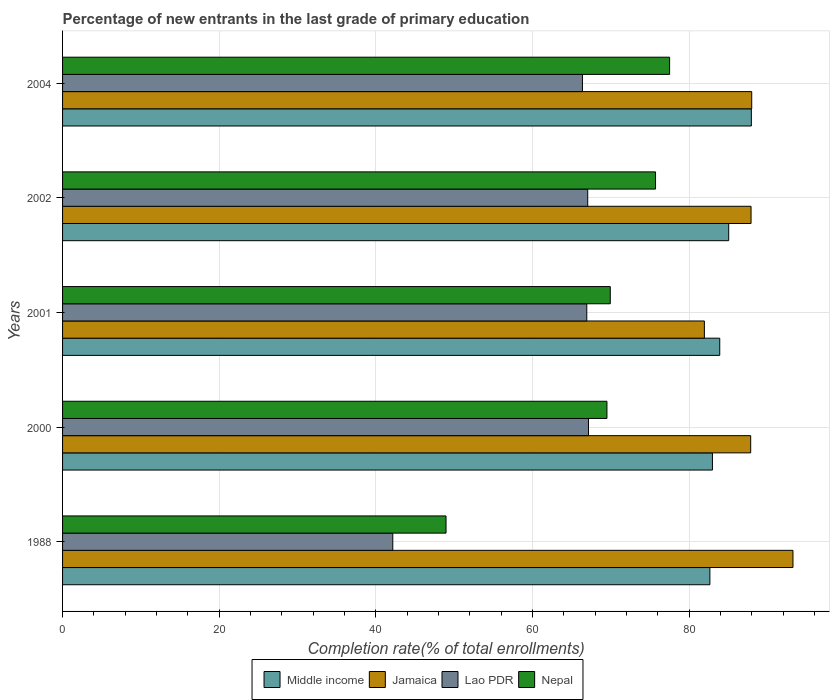How many groups of bars are there?
Provide a short and direct response. 5. How many bars are there on the 3rd tick from the top?
Your answer should be very brief. 4. How many bars are there on the 4th tick from the bottom?
Your answer should be very brief. 4. What is the percentage of new entrants in Jamaica in 2001?
Keep it short and to the point. 81.95. Across all years, what is the maximum percentage of new entrants in Jamaica?
Ensure brevity in your answer.  93.26. Across all years, what is the minimum percentage of new entrants in Nepal?
Your answer should be compact. 48.96. In which year was the percentage of new entrants in Lao PDR minimum?
Give a very brief answer. 1988. What is the total percentage of new entrants in Middle income in the graph?
Ensure brevity in your answer.  422.53. What is the difference between the percentage of new entrants in Middle income in 2000 and that in 2001?
Give a very brief answer. -0.93. What is the difference between the percentage of new entrants in Middle income in 2004 and the percentage of new entrants in Lao PDR in 2002?
Keep it short and to the point. 20.89. What is the average percentage of new entrants in Lao PDR per year?
Make the answer very short. 61.93. In the year 1988, what is the difference between the percentage of new entrants in Lao PDR and percentage of new entrants in Nepal?
Your answer should be very brief. -6.8. In how many years, is the percentage of new entrants in Jamaica greater than 24 %?
Your answer should be very brief. 5. What is the ratio of the percentage of new entrants in Nepal in 1988 to that in 2004?
Keep it short and to the point. 0.63. Is the percentage of new entrants in Middle income in 1988 less than that in 2004?
Your answer should be compact. Yes. What is the difference between the highest and the second highest percentage of new entrants in Nepal?
Your answer should be compact. 1.8. What is the difference between the highest and the lowest percentage of new entrants in Middle income?
Make the answer very short. 5.29. In how many years, is the percentage of new entrants in Nepal greater than the average percentage of new entrants in Nepal taken over all years?
Keep it short and to the point. 4. Is the sum of the percentage of new entrants in Middle income in 2000 and 2004 greater than the maximum percentage of new entrants in Nepal across all years?
Ensure brevity in your answer.  Yes. Is it the case that in every year, the sum of the percentage of new entrants in Jamaica and percentage of new entrants in Lao PDR is greater than the sum of percentage of new entrants in Nepal and percentage of new entrants in Middle income?
Provide a short and direct response. No. What does the 1st bar from the top in 2001 represents?
Ensure brevity in your answer.  Nepal. What does the 1st bar from the bottom in 2001 represents?
Offer a very short reply. Middle income. Is it the case that in every year, the sum of the percentage of new entrants in Jamaica and percentage of new entrants in Lao PDR is greater than the percentage of new entrants in Middle income?
Offer a very short reply. Yes. How many years are there in the graph?
Give a very brief answer. 5. What is the difference between two consecutive major ticks on the X-axis?
Ensure brevity in your answer.  20. Are the values on the major ticks of X-axis written in scientific E-notation?
Keep it short and to the point. No. Where does the legend appear in the graph?
Your response must be concise. Bottom center. How are the legend labels stacked?
Your answer should be compact. Horizontal. What is the title of the graph?
Your answer should be very brief. Percentage of new entrants in the last grade of primary education. Does "Gabon" appear as one of the legend labels in the graph?
Your answer should be compact. No. What is the label or title of the X-axis?
Provide a succinct answer. Completion rate(% of total enrollments). What is the Completion rate(% of total enrollments) in Middle income in 1988?
Ensure brevity in your answer.  82.65. What is the Completion rate(% of total enrollments) of Jamaica in 1988?
Ensure brevity in your answer.  93.26. What is the Completion rate(% of total enrollments) of Lao PDR in 1988?
Give a very brief answer. 42.16. What is the Completion rate(% of total enrollments) in Nepal in 1988?
Ensure brevity in your answer.  48.96. What is the Completion rate(% of total enrollments) in Middle income in 2000?
Your answer should be very brief. 82.97. What is the Completion rate(% of total enrollments) of Jamaica in 2000?
Make the answer very short. 87.86. What is the Completion rate(% of total enrollments) of Lao PDR in 2000?
Your answer should be compact. 67.15. What is the Completion rate(% of total enrollments) in Nepal in 2000?
Offer a very short reply. 69.51. What is the Completion rate(% of total enrollments) of Middle income in 2001?
Offer a terse response. 83.91. What is the Completion rate(% of total enrollments) in Jamaica in 2001?
Give a very brief answer. 81.95. What is the Completion rate(% of total enrollments) in Lao PDR in 2001?
Keep it short and to the point. 66.93. What is the Completion rate(% of total enrollments) of Nepal in 2001?
Offer a very short reply. 69.93. What is the Completion rate(% of total enrollments) of Middle income in 2002?
Your response must be concise. 85.05. What is the Completion rate(% of total enrollments) in Jamaica in 2002?
Your answer should be compact. 87.91. What is the Completion rate(% of total enrollments) of Lao PDR in 2002?
Offer a terse response. 67.05. What is the Completion rate(% of total enrollments) of Nepal in 2002?
Give a very brief answer. 75.71. What is the Completion rate(% of total enrollments) of Middle income in 2004?
Your answer should be compact. 87.94. What is the Completion rate(% of total enrollments) in Jamaica in 2004?
Ensure brevity in your answer.  87.99. What is the Completion rate(% of total enrollments) of Lao PDR in 2004?
Ensure brevity in your answer.  66.38. What is the Completion rate(% of total enrollments) of Nepal in 2004?
Offer a very short reply. 77.51. Across all years, what is the maximum Completion rate(% of total enrollments) in Middle income?
Provide a short and direct response. 87.94. Across all years, what is the maximum Completion rate(% of total enrollments) in Jamaica?
Your answer should be very brief. 93.26. Across all years, what is the maximum Completion rate(% of total enrollments) in Lao PDR?
Offer a very short reply. 67.15. Across all years, what is the maximum Completion rate(% of total enrollments) of Nepal?
Offer a very short reply. 77.51. Across all years, what is the minimum Completion rate(% of total enrollments) in Middle income?
Your answer should be very brief. 82.65. Across all years, what is the minimum Completion rate(% of total enrollments) in Jamaica?
Provide a short and direct response. 81.95. Across all years, what is the minimum Completion rate(% of total enrollments) in Lao PDR?
Your answer should be very brief. 42.16. Across all years, what is the minimum Completion rate(% of total enrollments) in Nepal?
Offer a very short reply. 48.96. What is the total Completion rate(% of total enrollments) of Middle income in the graph?
Provide a succinct answer. 422.53. What is the total Completion rate(% of total enrollments) of Jamaica in the graph?
Ensure brevity in your answer.  438.96. What is the total Completion rate(% of total enrollments) in Lao PDR in the graph?
Your answer should be compact. 309.67. What is the total Completion rate(% of total enrollments) of Nepal in the graph?
Your answer should be compact. 341.61. What is the difference between the Completion rate(% of total enrollments) in Middle income in 1988 and that in 2000?
Ensure brevity in your answer.  -0.33. What is the difference between the Completion rate(% of total enrollments) in Jamaica in 1988 and that in 2000?
Your answer should be very brief. 5.4. What is the difference between the Completion rate(% of total enrollments) in Lao PDR in 1988 and that in 2000?
Offer a terse response. -24.99. What is the difference between the Completion rate(% of total enrollments) in Nepal in 1988 and that in 2000?
Provide a succinct answer. -20.55. What is the difference between the Completion rate(% of total enrollments) of Middle income in 1988 and that in 2001?
Ensure brevity in your answer.  -1.26. What is the difference between the Completion rate(% of total enrollments) in Jamaica in 1988 and that in 2001?
Offer a terse response. 11.31. What is the difference between the Completion rate(% of total enrollments) in Lao PDR in 1988 and that in 2001?
Ensure brevity in your answer.  -24.77. What is the difference between the Completion rate(% of total enrollments) of Nepal in 1988 and that in 2001?
Ensure brevity in your answer.  -20.97. What is the difference between the Completion rate(% of total enrollments) of Middle income in 1988 and that in 2002?
Provide a short and direct response. -2.4. What is the difference between the Completion rate(% of total enrollments) in Jamaica in 1988 and that in 2002?
Ensure brevity in your answer.  5.35. What is the difference between the Completion rate(% of total enrollments) of Lao PDR in 1988 and that in 2002?
Give a very brief answer. -24.89. What is the difference between the Completion rate(% of total enrollments) in Nepal in 1988 and that in 2002?
Provide a short and direct response. -26.75. What is the difference between the Completion rate(% of total enrollments) in Middle income in 1988 and that in 2004?
Offer a terse response. -5.29. What is the difference between the Completion rate(% of total enrollments) of Jamaica in 1988 and that in 2004?
Offer a terse response. 5.27. What is the difference between the Completion rate(% of total enrollments) in Lao PDR in 1988 and that in 2004?
Keep it short and to the point. -24.22. What is the difference between the Completion rate(% of total enrollments) in Nepal in 1988 and that in 2004?
Your answer should be very brief. -28.55. What is the difference between the Completion rate(% of total enrollments) of Middle income in 2000 and that in 2001?
Ensure brevity in your answer.  -0.93. What is the difference between the Completion rate(% of total enrollments) of Jamaica in 2000 and that in 2001?
Your response must be concise. 5.91. What is the difference between the Completion rate(% of total enrollments) of Lao PDR in 2000 and that in 2001?
Give a very brief answer. 0.22. What is the difference between the Completion rate(% of total enrollments) in Nepal in 2000 and that in 2001?
Give a very brief answer. -0.43. What is the difference between the Completion rate(% of total enrollments) of Middle income in 2000 and that in 2002?
Give a very brief answer. -2.08. What is the difference between the Completion rate(% of total enrollments) in Jamaica in 2000 and that in 2002?
Provide a succinct answer. -0.05. What is the difference between the Completion rate(% of total enrollments) of Lao PDR in 2000 and that in 2002?
Provide a short and direct response. 0.1. What is the difference between the Completion rate(% of total enrollments) in Nepal in 2000 and that in 2002?
Keep it short and to the point. -6.2. What is the difference between the Completion rate(% of total enrollments) in Middle income in 2000 and that in 2004?
Ensure brevity in your answer.  -4.97. What is the difference between the Completion rate(% of total enrollments) of Jamaica in 2000 and that in 2004?
Your response must be concise. -0.13. What is the difference between the Completion rate(% of total enrollments) of Lao PDR in 2000 and that in 2004?
Keep it short and to the point. 0.77. What is the difference between the Completion rate(% of total enrollments) of Nepal in 2000 and that in 2004?
Offer a very short reply. -8. What is the difference between the Completion rate(% of total enrollments) in Middle income in 2001 and that in 2002?
Give a very brief answer. -1.14. What is the difference between the Completion rate(% of total enrollments) of Jamaica in 2001 and that in 2002?
Make the answer very short. -5.96. What is the difference between the Completion rate(% of total enrollments) in Lao PDR in 2001 and that in 2002?
Ensure brevity in your answer.  -0.12. What is the difference between the Completion rate(% of total enrollments) of Nepal in 2001 and that in 2002?
Provide a succinct answer. -5.78. What is the difference between the Completion rate(% of total enrollments) in Middle income in 2001 and that in 2004?
Your response must be concise. -4.03. What is the difference between the Completion rate(% of total enrollments) in Jamaica in 2001 and that in 2004?
Provide a succinct answer. -6.04. What is the difference between the Completion rate(% of total enrollments) in Lao PDR in 2001 and that in 2004?
Your answer should be very brief. 0.55. What is the difference between the Completion rate(% of total enrollments) in Nepal in 2001 and that in 2004?
Your answer should be compact. -7.58. What is the difference between the Completion rate(% of total enrollments) of Middle income in 2002 and that in 2004?
Offer a terse response. -2.89. What is the difference between the Completion rate(% of total enrollments) in Jamaica in 2002 and that in 2004?
Make the answer very short. -0.08. What is the difference between the Completion rate(% of total enrollments) in Lao PDR in 2002 and that in 2004?
Give a very brief answer. 0.67. What is the difference between the Completion rate(% of total enrollments) of Nepal in 2002 and that in 2004?
Your response must be concise. -1.8. What is the difference between the Completion rate(% of total enrollments) in Middle income in 1988 and the Completion rate(% of total enrollments) in Jamaica in 2000?
Make the answer very short. -5.21. What is the difference between the Completion rate(% of total enrollments) of Middle income in 1988 and the Completion rate(% of total enrollments) of Lao PDR in 2000?
Your answer should be very brief. 15.5. What is the difference between the Completion rate(% of total enrollments) of Middle income in 1988 and the Completion rate(% of total enrollments) of Nepal in 2000?
Make the answer very short. 13.14. What is the difference between the Completion rate(% of total enrollments) of Jamaica in 1988 and the Completion rate(% of total enrollments) of Lao PDR in 2000?
Provide a succinct answer. 26.11. What is the difference between the Completion rate(% of total enrollments) of Jamaica in 1988 and the Completion rate(% of total enrollments) of Nepal in 2000?
Your answer should be compact. 23.75. What is the difference between the Completion rate(% of total enrollments) of Lao PDR in 1988 and the Completion rate(% of total enrollments) of Nepal in 2000?
Offer a very short reply. -27.34. What is the difference between the Completion rate(% of total enrollments) of Middle income in 1988 and the Completion rate(% of total enrollments) of Jamaica in 2001?
Offer a very short reply. 0.7. What is the difference between the Completion rate(% of total enrollments) in Middle income in 1988 and the Completion rate(% of total enrollments) in Lao PDR in 2001?
Your answer should be compact. 15.72. What is the difference between the Completion rate(% of total enrollments) of Middle income in 1988 and the Completion rate(% of total enrollments) of Nepal in 2001?
Your response must be concise. 12.72. What is the difference between the Completion rate(% of total enrollments) in Jamaica in 1988 and the Completion rate(% of total enrollments) in Lao PDR in 2001?
Your answer should be compact. 26.33. What is the difference between the Completion rate(% of total enrollments) of Jamaica in 1988 and the Completion rate(% of total enrollments) of Nepal in 2001?
Your answer should be compact. 23.33. What is the difference between the Completion rate(% of total enrollments) of Lao PDR in 1988 and the Completion rate(% of total enrollments) of Nepal in 2001?
Your answer should be compact. -27.77. What is the difference between the Completion rate(% of total enrollments) of Middle income in 1988 and the Completion rate(% of total enrollments) of Jamaica in 2002?
Your answer should be very brief. -5.26. What is the difference between the Completion rate(% of total enrollments) in Middle income in 1988 and the Completion rate(% of total enrollments) in Lao PDR in 2002?
Your response must be concise. 15.6. What is the difference between the Completion rate(% of total enrollments) of Middle income in 1988 and the Completion rate(% of total enrollments) of Nepal in 2002?
Provide a succinct answer. 6.94. What is the difference between the Completion rate(% of total enrollments) in Jamaica in 1988 and the Completion rate(% of total enrollments) in Lao PDR in 2002?
Provide a succinct answer. 26.21. What is the difference between the Completion rate(% of total enrollments) of Jamaica in 1988 and the Completion rate(% of total enrollments) of Nepal in 2002?
Your response must be concise. 17.55. What is the difference between the Completion rate(% of total enrollments) in Lao PDR in 1988 and the Completion rate(% of total enrollments) in Nepal in 2002?
Offer a very short reply. -33.55. What is the difference between the Completion rate(% of total enrollments) in Middle income in 1988 and the Completion rate(% of total enrollments) in Jamaica in 2004?
Make the answer very short. -5.34. What is the difference between the Completion rate(% of total enrollments) in Middle income in 1988 and the Completion rate(% of total enrollments) in Lao PDR in 2004?
Your response must be concise. 16.27. What is the difference between the Completion rate(% of total enrollments) in Middle income in 1988 and the Completion rate(% of total enrollments) in Nepal in 2004?
Your answer should be compact. 5.14. What is the difference between the Completion rate(% of total enrollments) in Jamaica in 1988 and the Completion rate(% of total enrollments) in Lao PDR in 2004?
Make the answer very short. 26.88. What is the difference between the Completion rate(% of total enrollments) of Jamaica in 1988 and the Completion rate(% of total enrollments) of Nepal in 2004?
Your answer should be compact. 15.75. What is the difference between the Completion rate(% of total enrollments) of Lao PDR in 1988 and the Completion rate(% of total enrollments) of Nepal in 2004?
Your answer should be compact. -35.35. What is the difference between the Completion rate(% of total enrollments) in Middle income in 2000 and the Completion rate(% of total enrollments) in Jamaica in 2001?
Keep it short and to the point. 1.03. What is the difference between the Completion rate(% of total enrollments) of Middle income in 2000 and the Completion rate(% of total enrollments) of Lao PDR in 2001?
Provide a succinct answer. 16.04. What is the difference between the Completion rate(% of total enrollments) of Middle income in 2000 and the Completion rate(% of total enrollments) of Nepal in 2001?
Ensure brevity in your answer.  13.04. What is the difference between the Completion rate(% of total enrollments) of Jamaica in 2000 and the Completion rate(% of total enrollments) of Lao PDR in 2001?
Your response must be concise. 20.93. What is the difference between the Completion rate(% of total enrollments) of Jamaica in 2000 and the Completion rate(% of total enrollments) of Nepal in 2001?
Offer a terse response. 17.93. What is the difference between the Completion rate(% of total enrollments) in Lao PDR in 2000 and the Completion rate(% of total enrollments) in Nepal in 2001?
Your answer should be very brief. -2.78. What is the difference between the Completion rate(% of total enrollments) of Middle income in 2000 and the Completion rate(% of total enrollments) of Jamaica in 2002?
Give a very brief answer. -4.93. What is the difference between the Completion rate(% of total enrollments) in Middle income in 2000 and the Completion rate(% of total enrollments) in Lao PDR in 2002?
Offer a terse response. 15.92. What is the difference between the Completion rate(% of total enrollments) of Middle income in 2000 and the Completion rate(% of total enrollments) of Nepal in 2002?
Keep it short and to the point. 7.27. What is the difference between the Completion rate(% of total enrollments) of Jamaica in 2000 and the Completion rate(% of total enrollments) of Lao PDR in 2002?
Your answer should be very brief. 20.81. What is the difference between the Completion rate(% of total enrollments) in Jamaica in 2000 and the Completion rate(% of total enrollments) in Nepal in 2002?
Provide a succinct answer. 12.15. What is the difference between the Completion rate(% of total enrollments) of Lao PDR in 2000 and the Completion rate(% of total enrollments) of Nepal in 2002?
Offer a terse response. -8.56. What is the difference between the Completion rate(% of total enrollments) in Middle income in 2000 and the Completion rate(% of total enrollments) in Jamaica in 2004?
Provide a succinct answer. -5.02. What is the difference between the Completion rate(% of total enrollments) of Middle income in 2000 and the Completion rate(% of total enrollments) of Lao PDR in 2004?
Ensure brevity in your answer.  16.6. What is the difference between the Completion rate(% of total enrollments) in Middle income in 2000 and the Completion rate(% of total enrollments) in Nepal in 2004?
Provide a short and direct response. 5.47. What is the difference between the Completion rate(% of total enrollments) of Jamaica in 2000 and the Completion rate(% of total enrollments) of Lao PDR in 2004?
Make the answer very short. 21.48. What is the difference between the Completion rate(% of total enrollments) of Jamaica in 2000 and the Completion rate(% of total enrollments) of Nepal in 2004?
Provide a short and direct response. 10.35. What is the difference between the Completion rate(% of total enrollments) of Lao PDR in 2000 and the Completion rate(% of total enrollments) of Nepal in 2004?
Offer a terse response. -10.36. What is the difference between the Completion rate(% of total enrollments) in Middle income in 2001 and the Completion rate(% of total enrollments) in Jamaica in 2002?
Ensure brevity in your answer.  -4. What is the difference between the Completion rate(% of total enrollments) of Middle income in 2001 and the Completion rate(% of total enrollments) of Lao PDR in 2002?
Ensure brevity in your answer.  16.86. What is the difference between the Completion rate(% of total enrollments) in Middle income in 2001 and the Completion rate(% of total enrollments) in Nepal in 2002?
Offer a very short reply. 8.2. What is the difference between the Completion rate(% of total enrollments) of Jamaica in 2001 and the Completion rate(% of total enrollments) of Lao PDR in 2002?
Offer a terse response. 14.89. What is the difference between the Completion rate(% of total enrollments) in Jamaica in 2001 and the Completion rate(% of total enrollments) in Nepal in 2002?
Your answer should be very brief. 6.24. What is the difference between the Completion rate(% of total enrollments) of Lao PDR in 2001 and the Completion rate(% of total enrollments) of Nepal in 2002?
Offer a terse response. -8.78. What is the difference between the Completion rate(% of total enrollments) of Middle income in 2001 and the Completion rate(% of total enrollments) of Jamaica in 2004?
Keep it short and to the point. -4.08. What is the difference between the Completion rate(% of total enrollments) of Middle income in 2001 and the Completion rate(% of total enrollments) of Lao PDR in 2004?
Make the answer very short. 17.53. What is the difference between the Completion rate(% of total enrollments) in Middle income in 2001 and the Completion rate(% of total enrollments) in Nepal in 2004?
Your answer should be very brief. 6.4. What is the difference between the Completion rate(% of total enrollments) of Jamaica in 2001 and the Completion rate(% of total enrollments) of Lao PDR in 2004?
Make the answer very short. 15.57. What is the difference between the Completion rate(% of total enrollments) in Jamaica in 2001 and the Completion rate(% of total enrollments) in Nepal in 2004?
Your answer should be very brief. 4.44. What is the difference between the Completion rate(% of total enrollments) of Lao PDR in 2001 and the Completion rate(% of total enrollments) of Nepal in 2004?
Your response must be concise. -10.58. What is the difference between the Completion rate(% of total enrollments) of Middle income in 2002 and the Completion rate(% of total enrollments) of Jamaica in 2004?
Your response must be concise. -2.94. What is the difference between the Completion rate(% of total enrollments) of Middle income in 2002 and the Completion rate(% of total enrollments) of Lao PDR in 2004?
Offer a very short reply. 18.68. What is the difference between the Completion rate(% of total enrollments) in Middle income in 2002 and the Completion rate(% of total enrollments) in Nepal in 2004?
Your answer should be very brief. 7.55. What is the difference between the Completion rate(% of total enrollments) of Jamaica in 2002 and the Completion rate(% of total enrollments) of Lao PDR in 2004?
Your response must be concise. 21.53. What is the difference between the Completion rate(% of total enrollments) of Jamaica in 2002 and the Completion rate(% of total enrollments) of Nepal in 2004?
Keep it short and to the point. 10.4. What is the difference between the Completion rate(% of total enrollments) of Lao PDR in 2002 and the Completion rate(% of total enrollments) of Nepal in 2004?
Your response must be concise. -10.46. What is the average Completion rate(% of total enrollments) of Middle income per year?
Offer a terse response. 84.51. What is the average Completion rate(% of total enrollments) of Jamaica per year?
Your answer should be compact. 87.79. What is the average Completion rate(% of total enrollments) of Lao PDR per year?
Ensure brevity in your answer.  61.93. What is the average Completion rate(% of total enrollments) of Nepal per year?
Your response must be concise. 68.32. In the year 1988, what is the difference between the Completion rate(% of total enrollments) of Middle income and Completion rate(% of total enrollments) of Jamaica?
Provide a succinct answer. -10.61. In the year 1988, what is the difference between the Completion rate(% of total enrollments) in Middle income and Completion rate(% of total enrollments) in Lao PDR?
Provide a short and direct response. 40.49. In the year 1988, what is the difference between the Completion rate(% of total enrollments) of Middle income and Completion rate(% of total enrollments) of Nepal?
Make the answer very short. 33.69. In the year 1988, what is the difference between the Completion rate(% of total enrollments) in Jamaica and Completion rate(% of total enrollments) in Lao PDR?
Your response must be concise. 51.1. In the year 1988, what is the difference between the Completion rate(% of total enrollments) in Jamaica and Completion rate(% of total enrollments) in Nepal?
Keep it short and to the point. 44.3. In the year 1988, what is the difference between the Completion rate(% of total enrollments) of Lao PDR and Completion rate(% of total enrollments) of Nepal?
Make the answer very short. -6.8. In the year 2000, what is the difference between the Completion rate(% of total enrollments) in Middle income and Completion rate(% of total enrollments) in Jamaica?
Offer a very short reply. -4.88. In the year 2000, what is the difference between the Completion rate(% of total enrollments) in Middle income and Completion rate(% of total enrollments) in Lao PDR?
Provide a short and direct response. 15.83. In the year 2000, what is the difference between the Completion rate(% of total enrollments) in Middle income and Completion rate(% of total enrollments) in Nepal?
Offer a terse response. 13.47. In the year 2000, what is the difference between the Completion rate(% of total enrollments) of Jamaica and Completion rate(% of total enrollments) of Lao PDR?
Your answer should be very brief. 20.71. In the year 2000, what is the difference between the Completion rate(% of total enrollments) in Jamaica and Completion rate(% of total enrollments) in Nepal?
Your response must be concise. 18.35. In the year 2000, what is the difference between the Completion rate(% of total enrollments) in Lao PDR and Completion rate(% of total enrollments) in Nepal?
Ensure brevity in your answer.  -2.36. In the year 2001, what is the difference between the Completion rate(% of total enrollments) in Middle income and Completion rate(% of total enrollments) in Jamaica?
Ensure brevity in your answer.  1.96. In the year 2001, what is the difference between the Completion rate(% of total enrollments) of Middle income and Completion rate(% of total enrollments) of Lao PDR?
Your response must be concise. 16.98. In the year 2001, what is the difference between the Completion rate(% of total enrollments) in Middle income and Completion rate(% of total enrollments) in Nepal?
Offer a very short reply. 13.98. In the year 2001, what is the difference between the Completion rate(% of total enrollments) in Jamaica and Completion rate(% of total enrollments) in Lao PDR?
Ensure brevity in your answer.  15.01. In the year 2001, what is the difference between the Completion rate(% of total enrollments) of Jamaica and Completion rate(% of total enrollments) of Nepal?
Your response must be concise. 12.01. In the year 2001, what is the difference between the Completion rate(% of total enrollments) of Lao PDR and Completion rate(% of total enrollments) of Nepal?
Provide a succinct answer. -3. In the year 2002, what is the difference between the Completion rate(% of total enrollments) of Middle income and Completion rate(% of total enrollments) of Jamaica?
Your answer should be compact. -2.85. In the year 2002, what is the difference between the Completion rate(% of total enrollments) in Middle income and Completion rate(% of total enrollments) in Lao PDR?
Ensure brevity in your answer.  18. In the year 2002, what is the difference between the Completion rate(% of total enrollments) in Middle income and Completion rate(% of total enrollments) in Nepal?
Provide a succinct answer. 9.34. In the year 2002, what is the difference between the Completion rate(% of total enrollments) in Jamaica and Completion rate(% of total enrollments) in Lao PDR?
Provide a succinct answer. 20.85. In the year 2002, what is the difference between the Completion rate(% of total enrollments) of Jamaica and Completion rate(% of total enrollments) of Nepal?
Make the answer very short. 12.2. In the year 2002, what is the difference between the Completion rate(% of total enrollments) in Lao PDR and Completion rate(% of total enrollments) in Nepal?
Your answer should be compact. -8.66. In the year 2004, what is the difference between the Completion rate(% of total enrollments) of Middle income and Completion rate(% of total enrollments) of Jamaica?
Keep it short and to the point. -0.05. In the year 2004, what is the difference between the Completion rate(% of total enrollments) of Middle income and Completion rate(% of total enrollments) of Lao PDR?
Provide a short and direct response. 21.57. In the year 2004, what is the difference between the Completion rate(% of total enrollments) of Middle income and Completion rate(% of total enrollments) of Nepal?
Provide a succinct answer. 10.44. In the year 2004, what is the difference between the Completion rate(% of total enrollments) in Jamaica and Completion rate(% of total enrollments) in Lao PDR?
Make the answer very short. 21.61. In the year 2004, what is the difference between the Completion rate(% of total enrollments) in Jamaica and Completion rate(% of total enrollments) in Nepal?
Make the answer very short. 10.48. In the year 2004, what is the difference between the Completion rate(% of total enrollments) in Lao PDR and Completion rate(% of total enrollments) in Nepal?
Keep it short and to the point. -11.13. What is the ratio of the Completion rate(% of total enrollments) of Middle income in 1988 to that in 2000?
Offer a terse response. 1. What is the ratio of the Completion rate(% of total enrollments) in Jamaica in 1988 to that in 2000?
Your answer should be very brief. 1.06. What is the ratio of the Completion rate(% of total enrollments) of Lao PDR in 1988 to that in 2000?
Give a very brief answer. 0.63. What is the ratio of the Completion rate(% of total enrollments) in Nepal in 1988 to that in 2000?
Your answer should be very brief. 0.7. What is the ratio of the Completion rate(% of total enrollments) in Jamaica in 1988 to that in 2001?
Ensure brevity in your answer.  1.14. What is the ratio of the Completion rate(% of total enrollments) in Lao PDR in 1988 to that in 2001?
Provide a short and direct response. 0.63. What is the ratio of the Completion rate(% of total enrollments) in Nepal in 1988 to that in 2001?
Your response must be concise. 0.7. What is the ratio of the Completion rate(% of total enrollments) of Middle income in 1988 to that in 2002?
Offer a terse response. 0.97. What is the ratio of the Completion rate(% of total enrollments) of Jamaica in 1988 to that in 2002?
Provide a succinct answer. 1.06. What is the ratio of the Completion rate(% of total enrollments) in Lao PDR in 1988 to that in 2002?
Your answer should be compact. 0.63. What is the ratio of the Completion rate(% of total enrollments) in Nepal in 1988 to that in 2002?
Offer a terse response. 0.65. What is the ratio of the Completion rate(% of total enrollments) in Middle income in 1988 to that in 2004?
Make the answer very short. 0.94. What is the ratio of the Completion rate(% of total enrollments) in Jamaica in 1988 to that in 2004?
Provide a short and direct response. 1.06. What is the ratio of the Completion rate(% of total enrollments) in Lao PDR in 1988 to that in 2004?
Ensure brevity in your answer.  0.64. What is the ratio of the Completion rate(% of total enrollments) in Nepal in 1988 to that in 2004?
Give a very brief answer. 0.63. What is the ratio of the Completion rate(% of total enrollments) of Middle income in 2000 to that in 2001?
Offer a very short reply. 0.99. What is the ratio of the Completion rate(% of total enrollments) of Jamaica in 2000 to that in 2001?
Give a very brief answer. 1.07. What is the ratio of the Completion rate(% of total enrollments) of Lao PDR in 2000 to that in 2001?
Ensure brevity in your answer.  1. What is the ratio of the Completion rate(% of total enrollments) of Nepal in 2000 to that in 2001?
Give a very brief answer. 0.99. What is the ratio of the Completion rate(% of total enrollments) in Middle income in 2000 to that in 2002?
Offer a very short reply. 0.98. What is the ratio of the Completion rate(% of total enrollments) in Lao PDR in 2000 to that in 2002?
Provide a short and direct response. 1. What is the ratio of the Completion rate(% of total enrollments) in Nepal in 2000 to that in 2002?
Offer a terse response. 0.92. What is the ratio of the Completion rate(% of total enrollments) of Middle income in 2000 to that in 2004?
Your answer should be very brief. 0.94. What is the ratio of the Completion rate(% of total enrollments) in Jamaica in 2000 to that in 2004?
Provide a succinct answer. 1. What is the ratio of the Completion rate(% of total enrollments) of Lao PDR in 2000 to that in 2004?
Make the answer very short. 1.01. What is the ratio of the Completion rate(% of total enrollments) of Nepal in 2000 to that in 2004?
Ensure brevity in your answer.  0.9. What is the ratio of the Completion rate(% of total enrollments) of Middle income in 2001 to that in 2002?
Your answer should be compact. 0.99. What is the ratio of the Completion rate(% of total enrollments) in Jamaica in 2001 to that in 2002?
Your answer should be compact. 0.93. What is the ratio of the Completion rate(% of total enrollments) of Nepal in 2001 to that in 2002?
Your response must be concise. 0.92. What is the ratio of the Completion rate(% of total enrollments) of Middle income in 2001 to that in 2004?
Make the answer very short. 0.95. What is the ratio of the Completion rate(% of total enrollments) of Jamaica in 2001 to that in 2004?
Provide a short and direct response. 0.93. What is the ratio of the Completion rate(% of total enrollments) in Lao PDR in 2001 to that in 2004?
Ensure brevity in your answer.  1.01. What is the ratio of the Completion rate(% of total enrollments) of Nepal in 2001 to that in 2004?
Give a very brief answer. 0.9. What is the ratio of the Completion rate(% of total enrollments) of Middle income in 2002 to that in 2004?
Your response must be concise. 0.97. What is the ratio of the Completion rate(% of total enrollments) of Jamaica in 2002 to that in 2004?
Keep it short and to the point. 1. What is the ratio of the Completion rate(% of total enrollments) in Lao PDR in 2002 to that in 2004?
Offer a terse response. 1.01. What is the ratio of the Completion rate(% of total enrollments) in Nepal in 2002 to that in 2004?
Offer a very short reply. 0.98. What is the difference between the highest and the second highest Completion rate(% of total enrollments) of Middle income?
Offer a terse response. 2.89. What is the difference between the highest and the second highest Completion rate(% of total enrollments) of Jamaica?
Your answer should be very brief. 5.27. What is the difference between the highest and the second highest Completion rate(% of total enrollments) in Lao PDR?
Provide a succinct answer. 0.1. What is the difference between the highest and the second highest Completion rate(% of total enrollments) of Nepal?
Make the answer very short. 1.8. What is the difference between the highest and the lowest Completion rate(% of total enrollments) in Middle income?
Offer a very short reply. 5.29. What is the difference between the highest and the lowest Completion rate(% of total enrollments) of Jamaica?
Your answer should be compact. 11.31. What is the difference between the highest and the lowest Completion rate(% of total enrollments) in Lao PDR?
Provide a short and direct response. 24.99. What is the difference between the highest and the lowest Completion rate(% of total enrollments) in Nepal?
Ensure brevity in your answer.  28.55. 